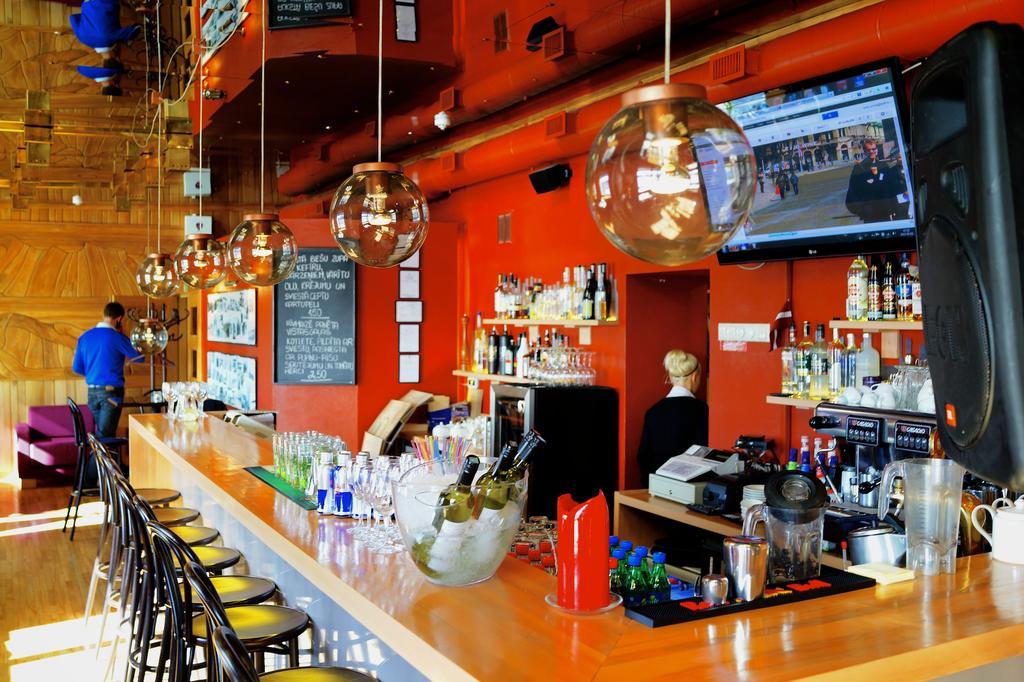Could you give a brief overview of what you see in this image? In this image we can see the inner view of a room. In the room there are person standing on the floor, electric lights, menu board, wall hangings to the walls, beverage tins, beverage bottles, disposal bottles, chairs on the floor, display screen to the wall and a pipeline. 